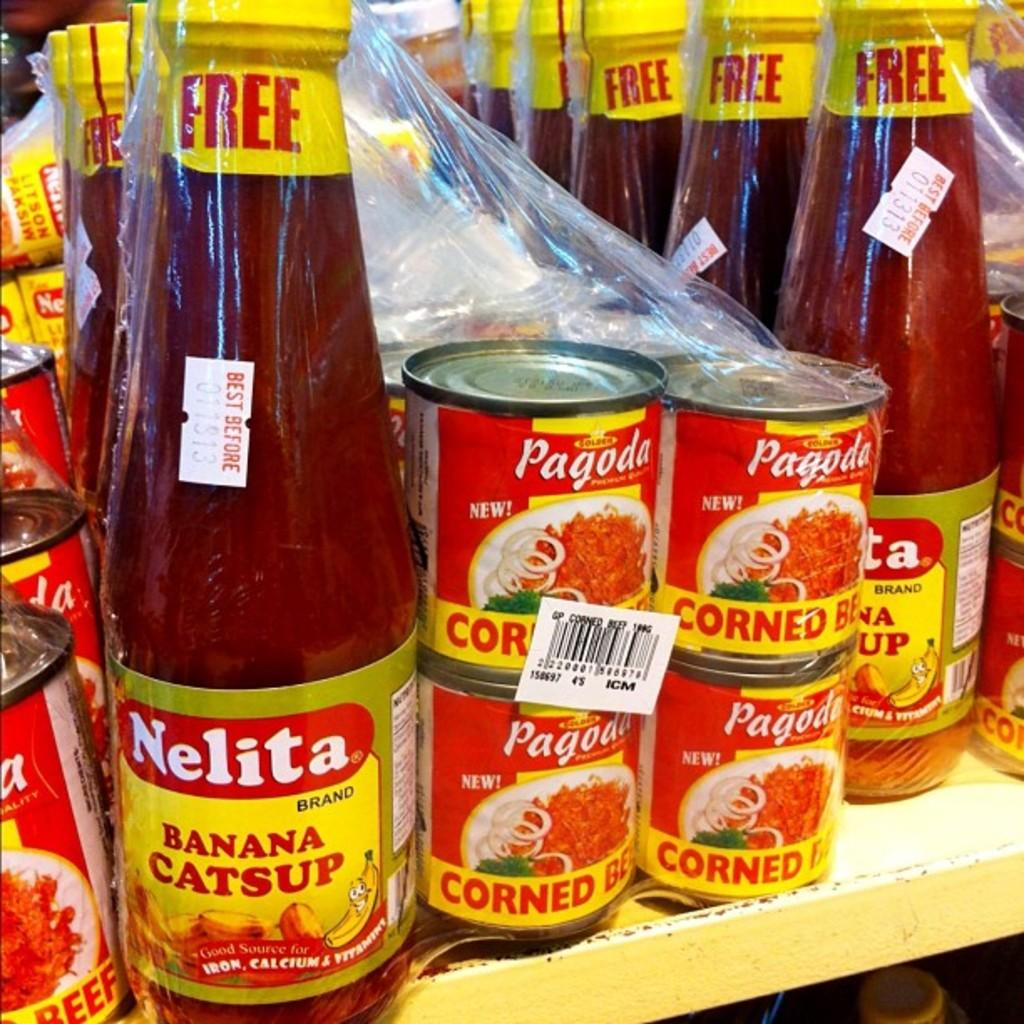Provide a one-sentence caption for the provided image. Some Nelita and Pagoda products fill a store shelf. 